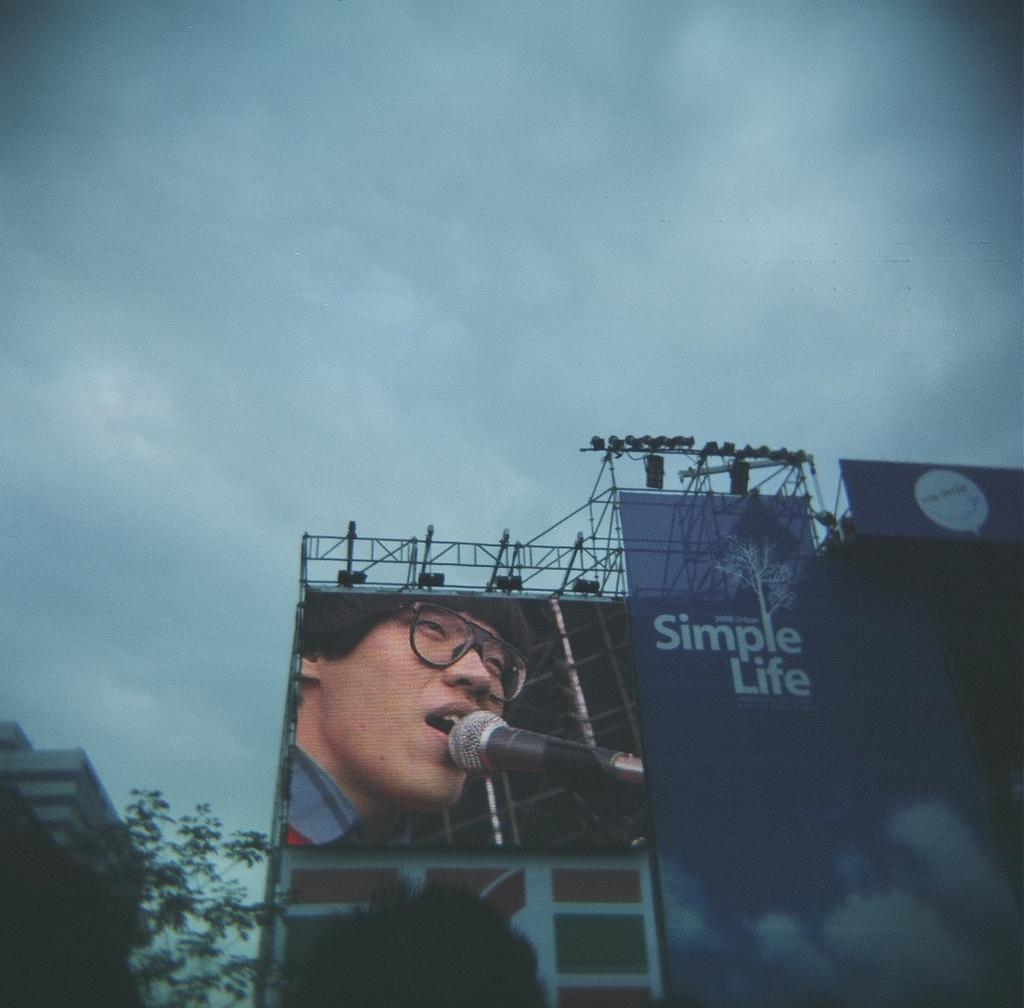Describe this image in one or two sentences. In this image there is a hoarding. There is text on the hoarding. Beside it there is a display screen. On the screen there is a face of a person displayed. In front of the person there is a microphone. To the left there is a building. At the top there is the sky. 